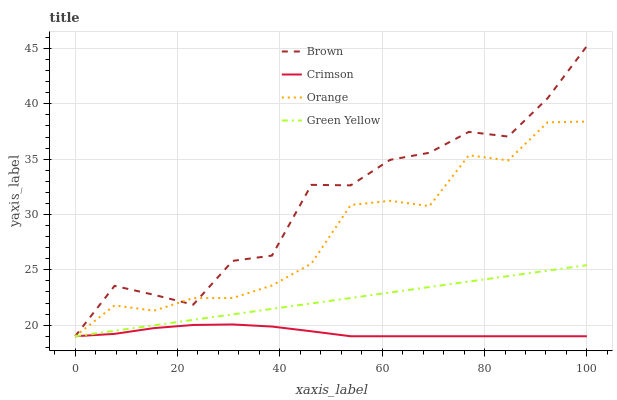Does Crimson have the minimum area under the curve?
Answer yes or no. Yes. Does Brown have the maximum area under the curve?
Answer yes or no. Yes. Does Orange have the minimum area under the curve?
Answer yes or no. No. Does Orange have the maximum area under the curve?
Answer yes or no. No. Is Green Yellow the smoothest?
Answer yes or no. Yes. Is Brown the roughest?
Answer yes or no. Yes. Is Orange the smoothest?
Answer yes or no. No. Is Orange the roughest?
Answer yes or no. No. Does Crimson have the lowest value?
Answer yes or no. Yes. Does Brown have the highest value?
Answer yes or no. Yes. Does Orange have the highest value?
Answer yes or no. No. Does Brown intersect Green Yellow?
Answer yes or no. Yes. Is Brown less than Green Yellow?
Answer yes or no. No. Is Brown greater than Green Yellow?
Answer yes or no. No. 